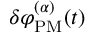Convert formula to latex. <formula><loc_0><loc_0><loc_500><loc_500>\delta \varphi _ { P M } ^ { ( \alpha ) } ( t )</formula> 